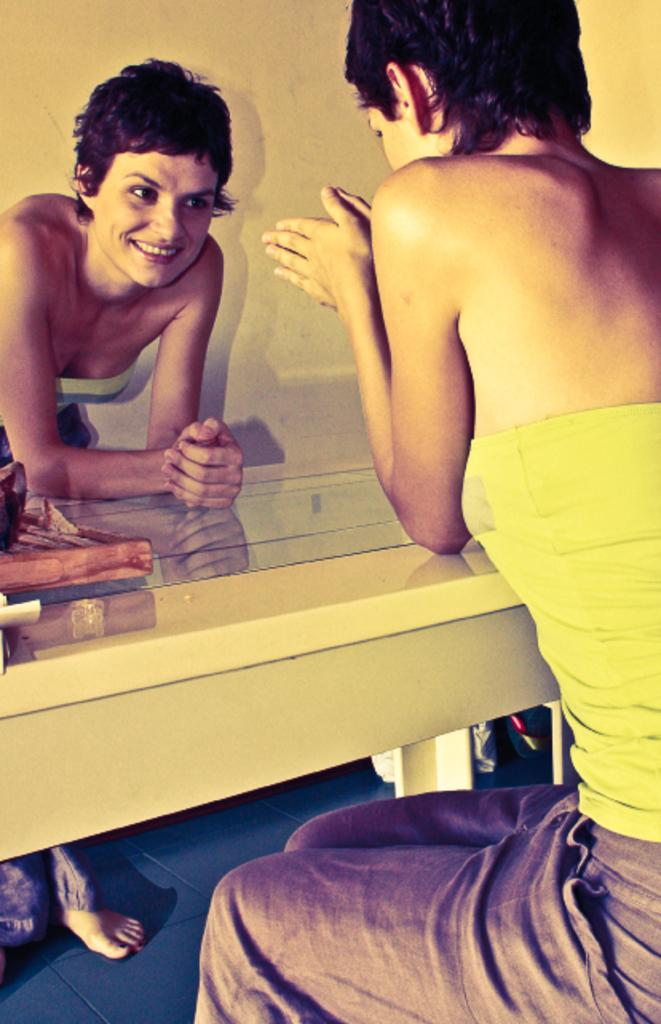How many people are in the image? There are two persons in the image. What is the position of one of the persons? One person is sitting. What is on the floor in the image? There is a table on the floor. What can be seen in the background of the image? There is a wall in the background of the image. What type of cow can be seen grazing on the table in the image? There is no cow present in the image, and therefore no cow can be seen grazing on the table. What is the purpose of the calculator on the table in the image? There is no calculator present in the image, so it cannot be determined what its purpose might be. 